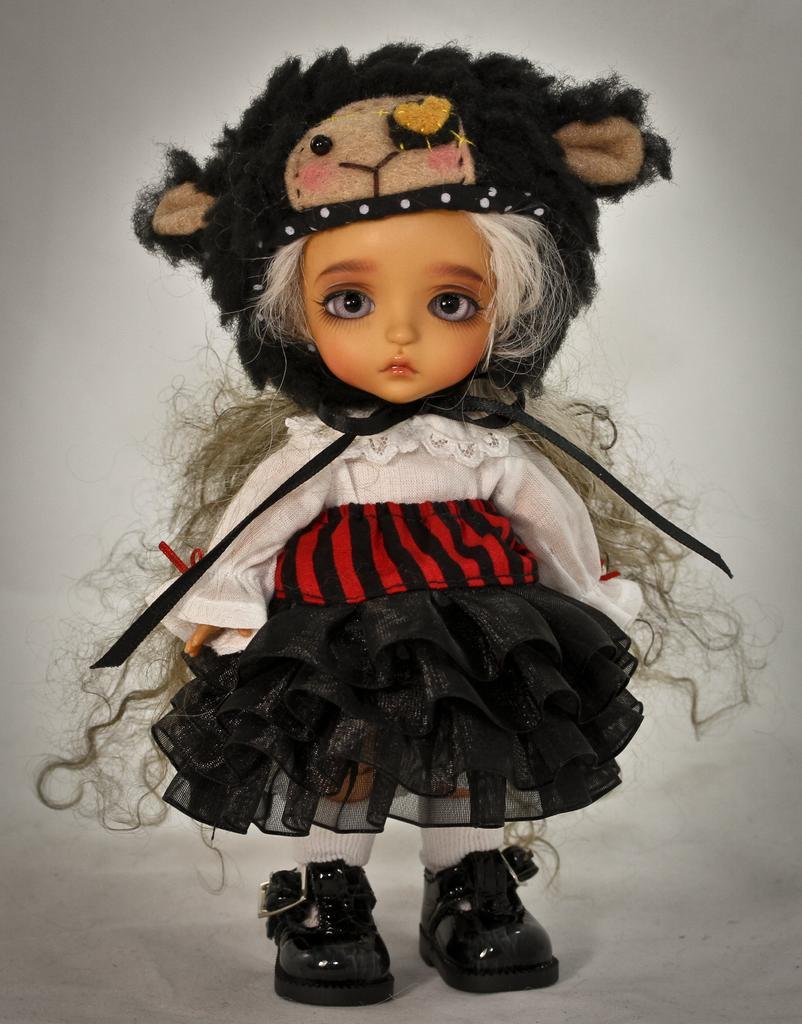Could you give a brief overview of what you see in this image? In this image there is a toy, the background of the image is white in color. 